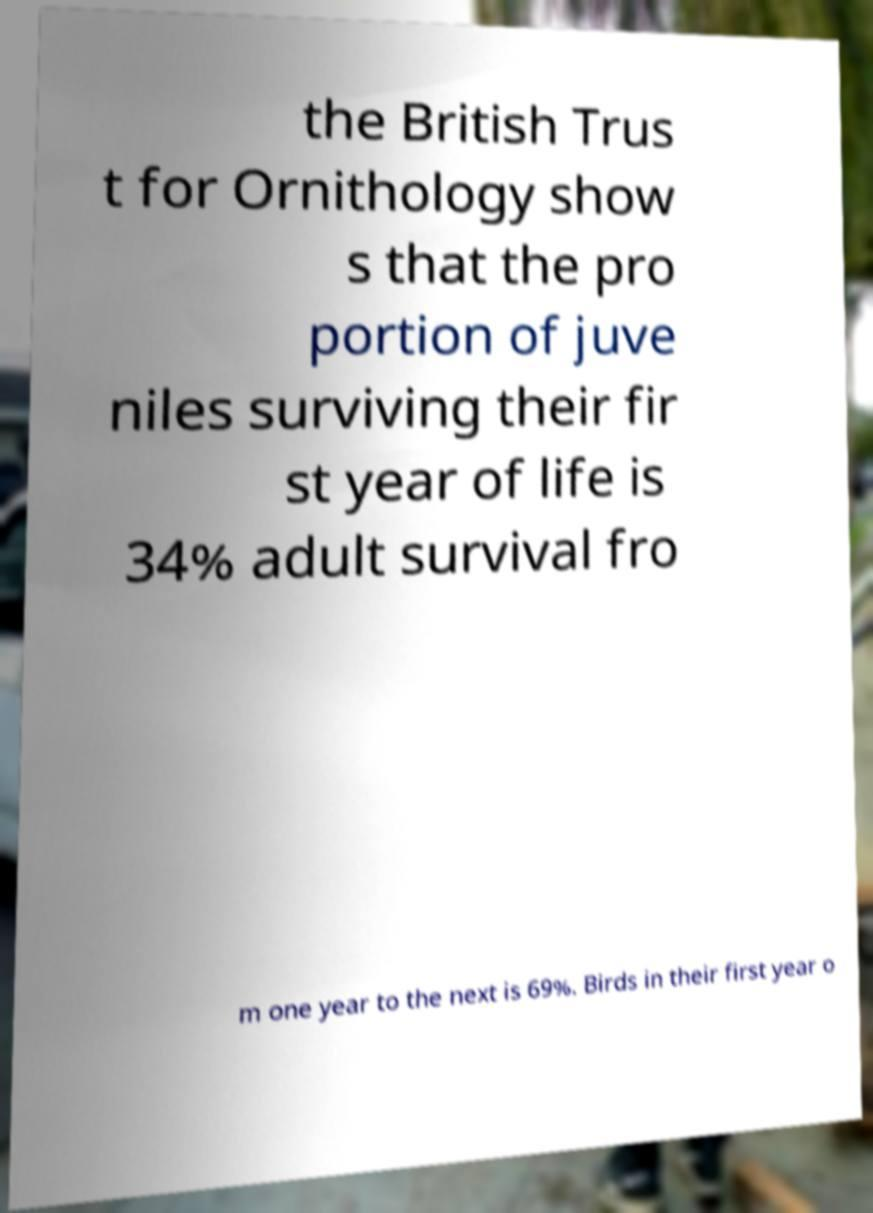Please read and relay the text visible in this image. What does it say? the British Trus t for Ornithology show s that the pro portion of juve niles surviving their fir st year of life is 34% adult survival fro m one year to the next is 69%. Birds in their first year o 